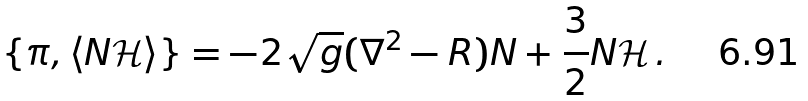Convert formula to latex. <formula><loc_0><loc_0><loc_500><loc_500>\{ \pi , \left < N \mathcal { H } \right > \} = - 2 \sqrt { g } ( \nabla ^ { 2 } - R ) N + \frac { 3 } { 2 } N \mathcal { H } \, .</formula> 